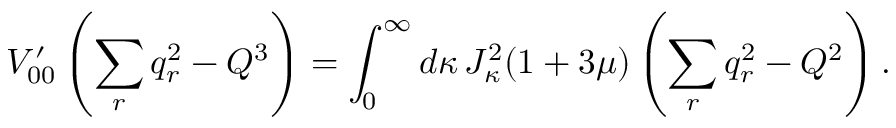<formula> <loc_0><loc_0><loc_500><loc_500>V _ { 0 0 } ^ { \prime } \left ( \sum _ { r } q _ { r } ^ { 2 } - Q ^ { 3 } \right ) = \int _ { 0 } ^ { \infty } d \kappa \, J _ { \kappa } ^ { 2 } ( 1 + 3 \mu ) \left ( \sum _ { r } q _ { r } ^ { 2 } - Q ^ { 2 } \right ) .</formula> 